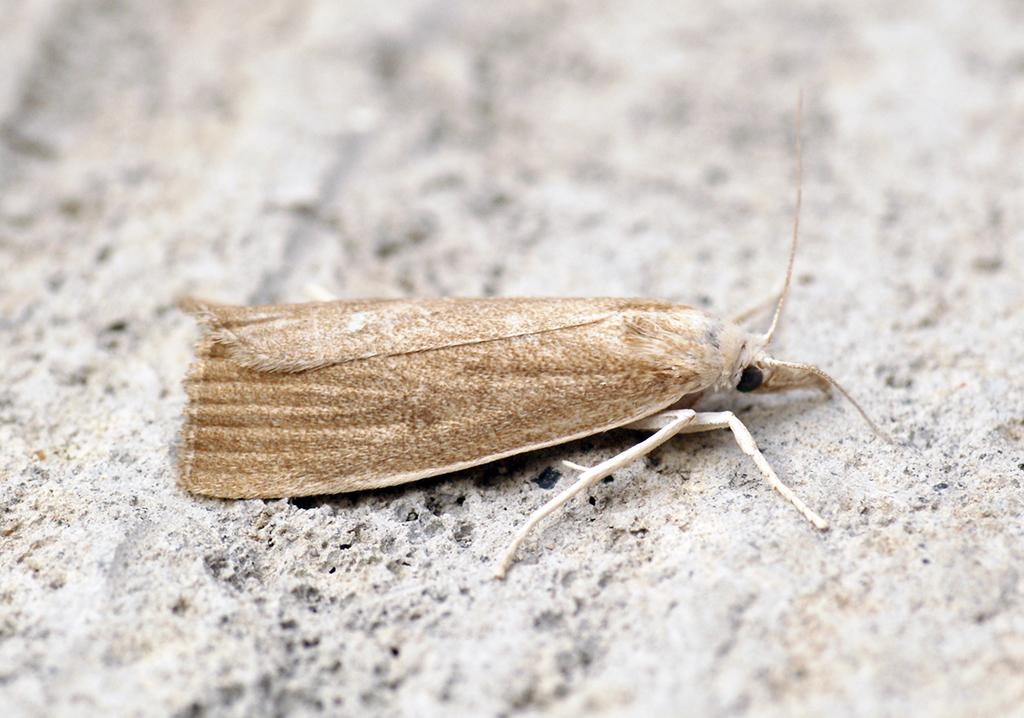What type of creature is present in the image? There is an insect in the image. What color is the insect? The insect is brown in color. What is the background of the image? There is a floor at the bottom of the image. What type of alarm can be heard in the image? There is no alarm present in the image, as it is a still image and cannot produce sound. 